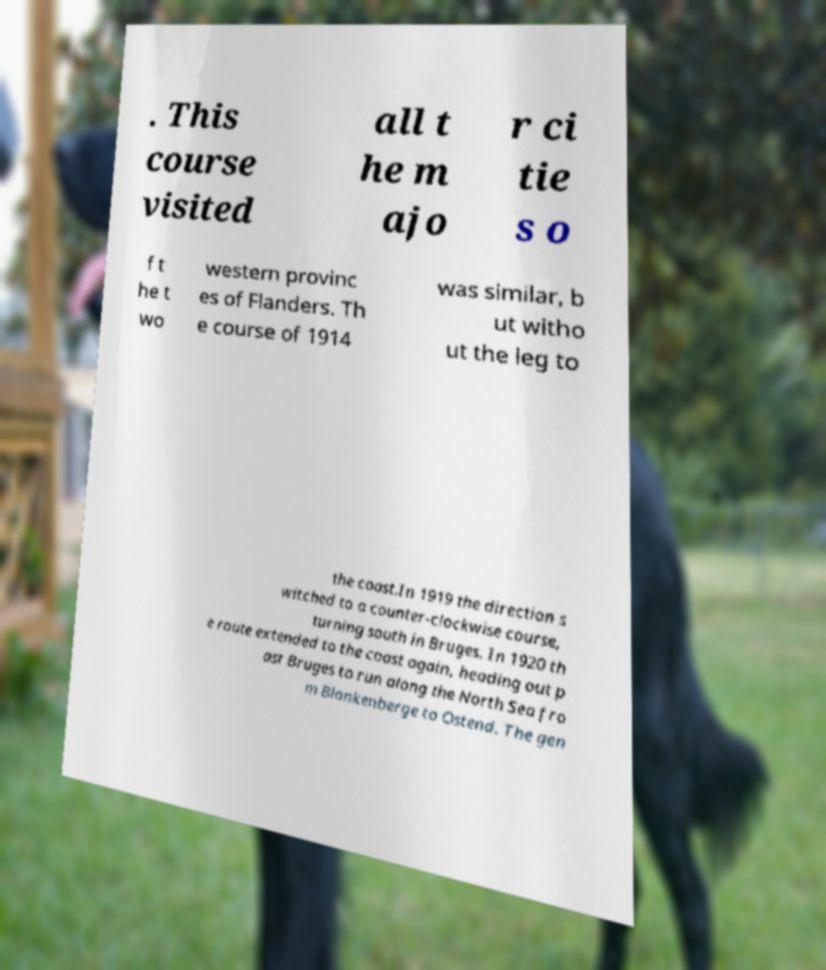Could you extract and type out the text from this image? . This course visited all t he m ajo r ci tie s o f t he t wo western provinc es of Flanders. Th e course of 1914 was similar, b ut witho ut the leg to the coast.In 1919 the direction s witched to a counter-clockwise course, turning south in Bruges. In 1920 th e route extended to the coast again, heading out p ast Bruges to run along the North Sea fro m Blankenberge to Ostend. The gen 